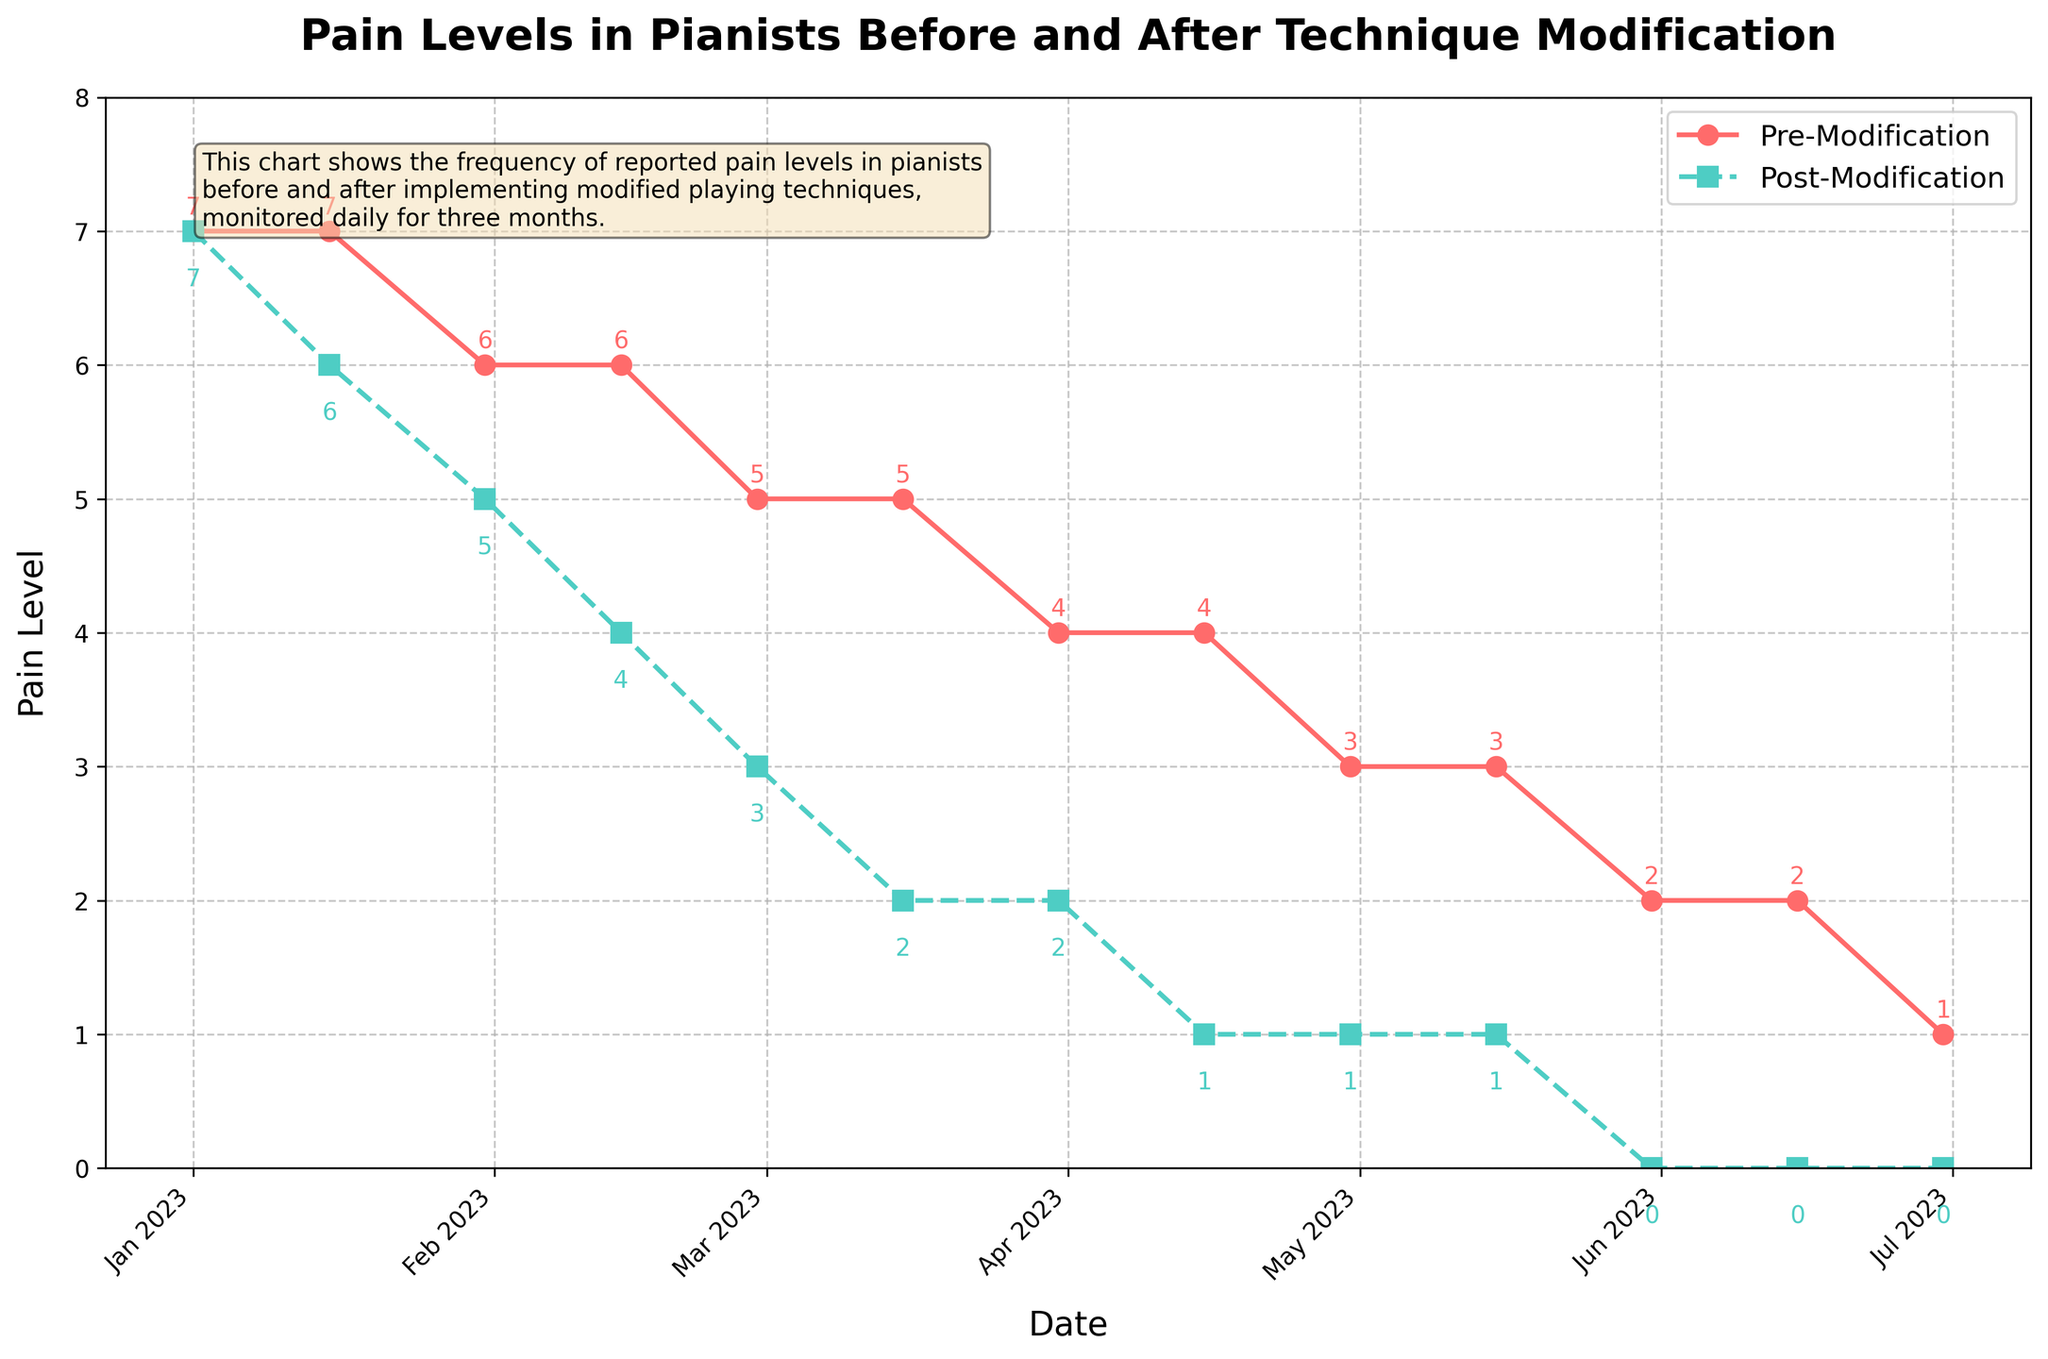What's the pain level before and after modification on 2023-02-28? Read the data point corresponding to 2023-02-28 for both lines: the red line (pre-modification) is at 5, and the green line (post-modification) is at 3.
Answer: 5 and 3 Which date shows the biggest gap between pre-modification and post-modification pain levels? Identify the greatest difference between the red and green lines. On 2023-05-31, the pre-modification pain level is 2, and the post-modification pain level is 0, giving a gap of 2.
Answer: 2023-05-31 How many times does the pre-modification pain level decrease in the chart? Count each time the pre-modification pain level decreases: it decreases from 7 to 6 (twice), 6 to 5, 5 to 4 (twice), 4 to 3, 3 to 2, and 2 to 1. So, there are 8 decreases total.
Answer: 8 What's the average post-modification pain level in March 2023? Identify the post-modification pain levels for 2023-03-15 and 2023-03-31 (2 and 2). Calculate the average: (2 + 2) / 2 = 2.
Answer: 2 Did the pre-modification pain level ever increase during the observation period? Check for any increases in the red line values across the chart. The pre-modification pain level only decreases or stays the same, so it does not increase.
Answer: No On 2023-04-15, by how much has the post-modification pain level decreased compared to the pre-modification level? Note the pre-modification pain level (4) and the post-modification level (1) on 2023-04-15. The decrease is 4 - 1 = 3.
Answer: 3 What is the color representing the post-modification pain level? Identify the color of the line marked as "Post-Modification" in the legend. The post-modification line is green with square markers.
Answer: Green What is the median pre-modification pain level? List all pre-modification pain levels in ascending order: 1, 2, 2, 3, 3, 4, 4, 5, 5, 6, 6, 7, 7. The middle value (median) is the 7th value, which is 4.
Answer: 4 Which date has the lowest post-modification pain level? Identify the lowest point on the green line. The post-modification pain level is 0 on 2023-05-31, 2023-06-15, and 2023-06-30.
Answer: 2023-05-31, 2023-06-15, 2023-06-30 